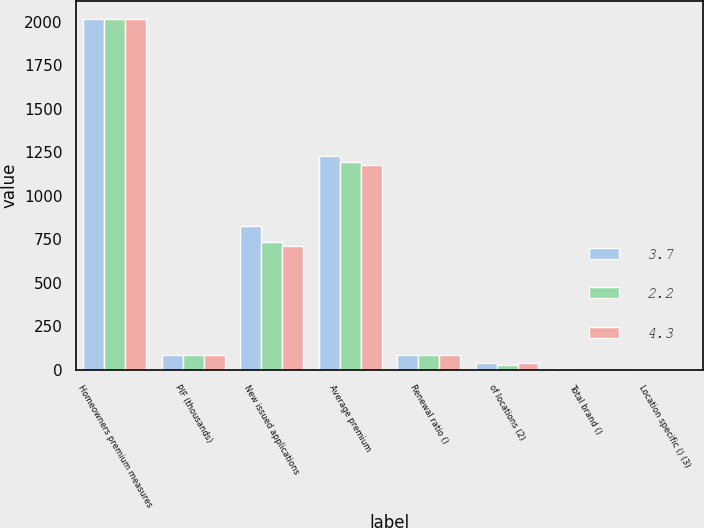<chart> <loc_0><loc_0><loc_500><loc_500><stacked_bar_chart><ecel><fcel>Homeowners premium measures<fcel>PIF (thousands)<fcel>New issued applications<fcel>Average premium<fcel>Renewal ratio ()<fcel>of locations (2)<fcel>Total brand ()<fcel>Location specific () (3)<nl><fcel>3.7<fcel>2018<fcel>87.8<fcel>826<fcel>1231<fcel>88<fcel>40<fcel>2.7<fcel>4.3<nl><fcel>2.2<fcel>2017<fcel>87.8<fcel>733<fcel>1197<fcel>87.3<fcel>30<fcel>1.8<fcel>3.7<nl><fcel>4.3<fcel>2016<fcel>87.8<fcel>712<fcel>1177<fcel>87.8<fcel>40<fcel>1.1<fcel>2.2<nl></chart> 